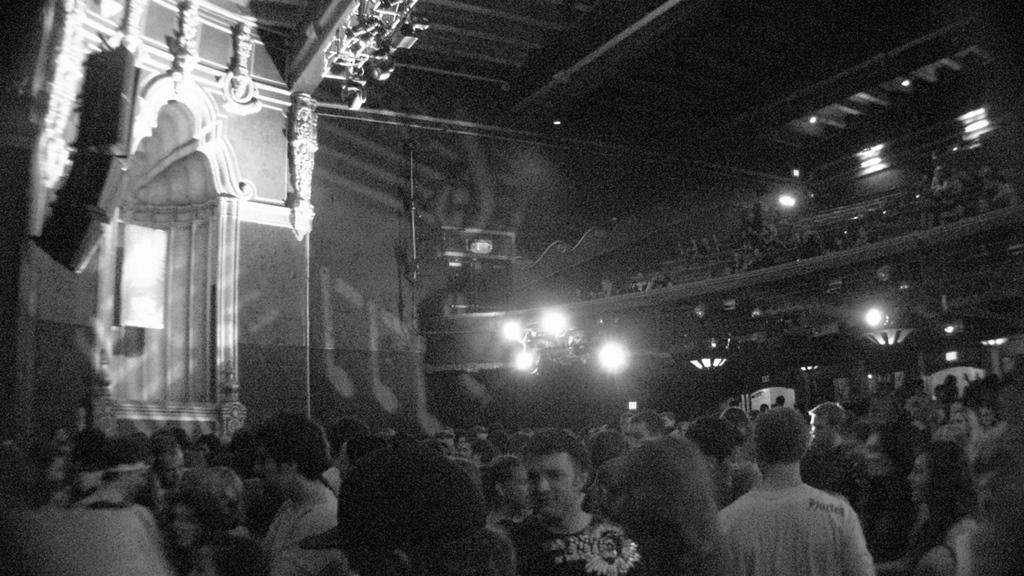Where are the people located in the image? There are people at the bottom side of the image. How many people can be seen in the image? There are other people in the image besides the ones at the bottom side. What can be seen in the background of the image? There is a roof and an arch in the background of the image. What is the source of light in the image? There is light visible in the image, possibly coming from spotlights at the top side of the image. What type of jam is being used to control the minds of the people in the image? There is no jam or mind control present in the image; it features people, a roof, an arch, and light. 